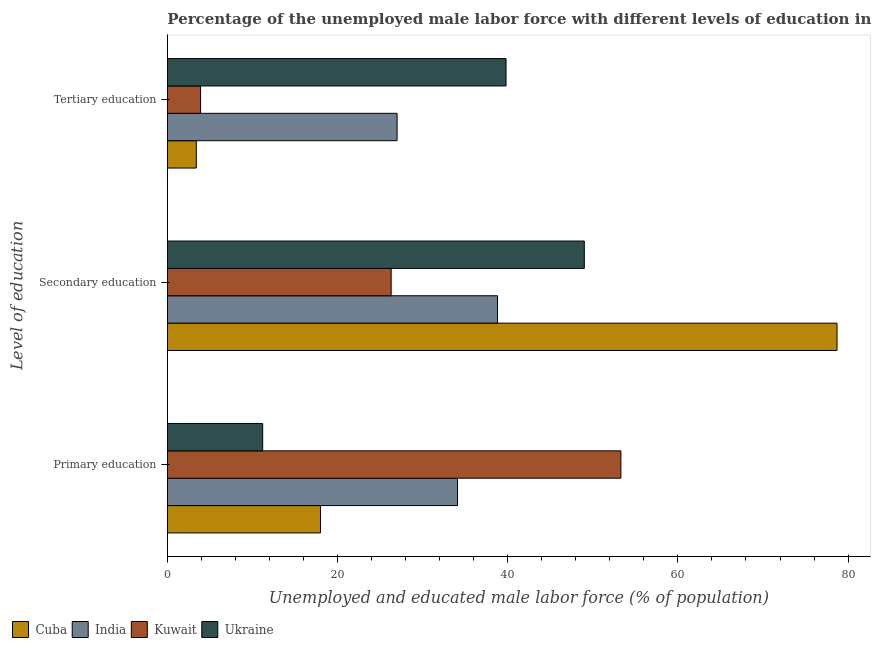How many different coloured bars are there?
Give a very brief answer. 4. Are the number of bars per tick equal to the number of legend labels?
Provide a short and direct response. Yes. How many bars are there on the 3rd tick from the bottom?
Your answer should be very brief. 4. What is the label of the 1st group of bars from the top?
Offer a very short reply. Tertiary education. What is the percentage of male labor force who received tertiary education in Kuwait?
Your response must be concise. 3.9. Across all countries, what is the maximum percentage of male labor force who received primary education?
Keep it short and to the point. 53.3. Across all countries, what is the minimum percentage of male labor force who received primary education?
Your answer should be very brief. 11.2. In which country was the percentage of male labor force who received tertiary education maximum?
Ensure brevity in your answer.  Ukraine. In which country was the percentage of male labor force who received tertiary education minimum?
Ensure brevity in your answer.  Cuba. What is the total percentage of male labor force who received secondary education in the graph?
Keep it short and to the point. 192.8. What is the difference between the percentage of male labor force who received tertiary education in Ukraine and that in Kuwait?
Provide a succinct answer. 35.9. What is the difference between the percentage of male labor force who received tertiary education in Kuwait and the percentage of male labor force who received secondary education in Cuba?
Keep it short and to the point. -74.8. What is the average percentage of male labor force who received primary education per country?
Give a very brief answer. 29.15. What is the difference between the percentage of male labor force who received tertiary education and percentage of male labor force who received secondary education in Cuba?
Your response must be concise. -75.3. In how many countries, is the percentage of male labor force who received secondary education greater than 48 %?
Offer a very short reply. 2. What is the ratio of the percentage of male labor force who received secondary education in Ukraine to that in India?
Your answer should be very brief. 1.26. Is the percentage of male labor force who received secondary education in India less than that in Kuwait?
Your answer should be compact. No. Is the difference between the percentage of male labor force who received tertiary education in Kuwait and Cuba greater than the difference between the percentage of male labor force who received secondary education in Kuwait and Cuba?
Keep it short and to the point. Yes. What is the difference between the highest and the second highest percentage of male labor force who received secondary education?
Ensure brevity in your answer.  29.7. What is the difference between the highest and the lowest percentage of male labor force who received primary education?
Your answer should be very brief. 42.1. In how many countries, is the percentage of male labor force who received tertiary education greater than the average percentage of male labor force who received tertiary education taken over all countries?
Offer a very short reply. 2. What does the 2nd bar from the top in Primary education represents?
Ensure brevity in your answer.  Kuwait. What does the 4th bar from the bottom in Tertiary education represents?
Ensure brevity in your answer.  Ukraine. Is it the case that in every country, the sum of the percentage of male labor force who received primary education and percentage of male labor force who received secondary education is greater than the percentage of male labor force who received tertiary education?
Give a very brief answer. Yes. How many countries are there in the graph?
Offer a very short reply. 4. Are the values on the major ticks of X-axis written in scientific E-notation?
Keep it short and to the point. No. Does the graph contain grids?
Your response must be concise. No. Where does the legend appear in the graph?
Offer a very short reply. Bottom left. What is the title of the graph?
Keep it short and to the point. Percentage of the unemployed male labor force with different levels of education in countries. Does "Tonga" appear as one of the legend labels in the graph?
Offer a terse response. No. What is the label or title of the X-axis?
Give a very brief answer. Unemployed and educated male labor force (% of population). What is the label or title of the Y-axis?
Provide a succinct answer. Level of education. What is the Unemployed and educated male labor force (% of population) of Cuba in Primary education?
Your answer should be compact. 18. What is the Unemployed and educated male labor force (% of population) of India in Primary education?
Keep it short and to the point. 34.1. What is the Unemployed and educated male labor force (% of population) of Kuwait in Primary education?
Give a very brief answer. 53.3. What is the Unemployed and educated male labor force (% of population) of Ukraine in Primary education?
Keep it short and to the point. 11.2. What is the Unemployed and educated male labor force (% of population) in Cuba in Secondary education?
Your answer should be very brief. 78.7. What is the Unemployed and educated male labor force (% of population) of India in Secondary education?
Give a very brief answer. 38.8. What is the Unemployed and educated male labor force (% of population) in Kuwait in Secondary education?
Provide a succinct answer. 26.3. What is the Unemployed and educated male labor force (% of population) of Cuba in Tertiary education?
Provide a short and direct response. 3.4. What is the Unemployed and educated male labor force (% of population) of India in Tertiary education?
Your answer should be compact. 27. What is the Unemployed and educated male labor force (% of population) of Kuwait in Tertiary education?
Keep it short and to the point. 3.9. What is the Unemployed and educated male labor force (% of population) of Ukraine in Tertiary education?
Keep it short and to the point. 39.8. Across all Level of education, what is the maximum Unemployed and educated male labor force (% of population) of Cuba?
Keep it short and to the point. 78.7. Across all Level of education, what is the maximum Unemployed and educated male labor force (% of population) of India?
Provide a succinct answer. 38.8. Across all Level of education, what is the maximum Unemployed and educated male labor force (% of population) in Kuwait?
Make the answer very short. 53.3. Across all Level of education, what is the minimum Unemployed and educated male labor force (% of population) of Cuba?
Keep it short and to the point. 3.4. Across all Level of education, what is the minimum Unemployed and educated male labor force (% of population) of Kuwait?
Provide a short and direct response. 3.9. Across all Level of education, what is the minimum Unemployed and educated male labor force (% of population) of Ukraine?
Your answer should be very brief. 11.2. What is the total Unemployed and educated male labor force (% of population) in Cuba in the graph?
Give a very brief answer. 100.1. What is the total Unemployed and educated male labor force (% of population) in India in the graph?
Your answer should be compact. 99.9. What is the total Unemployed and educated male labor force (% of population) in Kuwait in the graph?
Your answer should be compact. 83.5. What is the total Unemployed and educated male labor force (% of population) of Ukraine in the graph?
Your answer should be very brief. 100. What is the difference between the Unemployed and educated male labor force (% of population) in Cuba in Primary education and that in Secondary education?
Keep it short and to the point. -60.7. What is the difference between the Unemployed and educated male labor force (% of population) in Ukraine in Primary education and that in Secondary education?
Offer a very short reply. -37.8. What is the difference between the Unemployed and educated male labor force (% of population) of Kuwait in Primary education and that in Tertiary education?
Give a very brief answer. 49.4. What is the difference between the Unemployed and educated male labor force (% of population) of Ukraine in Primary education and that in Tertiary education?
Offer a very short reply. -28.6. What is the difference between the Unemployed and educated male labor force (% of population) in Cuba in Secondary education and that in Tertiary education?
Make the answer very short. 75.3. What is the difference between the Unemployed and educated male labor force (% of population) of Kuwait in Secondary education and that in Tertiary education?
Offer a terse response. 22.4. What is the difference between the Unemployed and educated male labor force (% of population) of Cuba in Primary education and the Unemployed and educated male labor force (% of population) of India in Secondary education?
Offer a terse response. -20.8. What is the difference between the Unemployed and educated male labor force (% of population) of Cuba in Primary education and the Unemployed and educated male labor force (% of population) of Ukraine in Secondary education?
Keep it short and to the point. -31. What is the difference between the Unemployed and educated male labor force (% of population) of India in Primary education and the Unemployed and educated male labor force (% of population) of Ukraine in Secondary education?
Provide a short and direct response. -14.9. What is the difference between the Unemployed and educated male labor force (% of population) of Cuba in Primary education and the Unemployed and educated male labor force (% of population) of India in Tertiary education?
Your answer should be very brief. -9. What is the difference between the Unemployed and educated male labor force (% of population) in Cuba in Primary education and the Unemployed and educated male labor force (% of population) in Kuwait in Tertiary education?
Make the answer very short. 14.1. What is the difference between the Unemployed and educated male labor force (% of population) in Cuba in Primary education and the Unemployed and educated male labor force (% of population) in Ukraine in Tertiary education?
Offer a terse response. -21.8. What is the difference between the Unemployed and educated male labor force (% of population) of India in Primary education and the Unemployed and educated male labor force (% of population) of Kuwait in Tertiary education?
Provide a short and direct response. 30.2. What is the difference between the Unemployed and educated male labor force (% of population) in India in Primary education and the Unemployed and educated male labor force (% of population) in Ukraine in Tertiary education?
Provide a short and direct response. -5.7. What is the difference between the Unemployed and educated male labor force (% of population) in Kuwait in Primary education and the Unemployed and educated male labor force (% of population) in Ukraine in Tertiary education?
Provide a succinct answer. 13.5. What is the difference between the Unemployed and educated male labor force (% of population) of Cuba in Secondary education and the Unemployed and educated male labor force (% of population) of India in Tertiary education?
Provide a short and direct response. 51.7. What is the difference between the Unemployed and educated male labor force (% of population) of Cuba in Secondary education and the Unemployed and educated male labor force (% of population) of Kuwait in Tertiary education?
Offer a terse response. 74.8. What is the difference between the Unemployed and educated male labor force (% of population) in Cuba in Secondary education and the Unemployed and educated male labor force (% of population) in Ukraine in Tertiary education?
Make the answer very short. 38.9. What is the difference between the Unemployed and educated male labor force (% of population) in India in Secondary education and the Unemployed and educated male labor force (% of population) in Kuwait in Tertiary education?
Your answer should be compact. 34.9. What is the average Unemployed and educated male labor force (% of population) of Cuba per Level of education?
Provide a short and direct response. 33.37. What is the average Unemployed and educated male labor force (% of population) in India per Level of education?
Provide a succinct answer. 33.3. What is the average Unemployed and educated male labor force (% of population) in Kuwait per Level of education?
Keep it short and to the point. 27.83. What is the average Unemployed and educated male labor force (% of population) of Ukraine per Level of education?
Keep it short and to the point. 33.33. What is the difference between the Unemployed and educated male labor force (% of population) in Cuba and Unemployed and educated male labor force (% of population) in India in Primary education?
Offer a very short reply. -16.1. What is the difference between the Unemployed and educated male labor force (% of population) in Cuba and Unemployed and educated male labor force (% of population) in Kuwait in Primary education?
Your response must be concise. -35.3. What is the difference between the Unemployed and educated male labor force (% of population) in Cuba and Unemployed and educated male labor force (% of population) in Ukraine in Primary education?
Ensure brevity in your answer.  6.8. What is the difference between the Unemployed and educated male labor force (% of population) of India and Unemployed and educated male labor force (% of population) of Kuwait in Primary education?
Ensure brevity in your answer.  -19.2. What is the difference between the Unemployed and educated male labor force (% of population) in India and Unemployed and educated male labor force (% of population) in Ukraine in Primary education?
Your response must be concise. 22.9. What is the difference between the Unemployed and educated male labor force (% of population) in Kuwait and Unemployed and educated male labor force (% of population) in Ukraine in Primary education?
Provide a short and direct response. 42.1. What is the difference between the Unemployed and educated male labor force (% of population) of Cuba and Unemployed and educated male labor force (% of population) of India in Secondary education?
Give a very brief answer. 39.9. What is the difference between the Unemployed and educated male labor force (% of population) of Cuba and Unemployed and educated male labor force (% of population) of Kuwait in Secondary education?
Make the answer very short. 52.4. What is the difference between the Unemployed and educated male labor force (% of population) of Cuba and Unemployed and educated male labor force (% of population) of Ukraine in Secondary education?
Your answer should be very brief. 29.7. What is the difference between the Unemployed and educated male labor force (% of population) in Kuwait and Unemployed and educated male labor force (% of population) in Ukraine in Secondary education?
Ensure brevity in your answer.  -22.7. What is the difference between the Unemployed and educated male labor force (% of population) in Cuba and Unemployed and educated male labor force (% of population) in India in Tertiary education?
Keep it short and to the point. -23.6. What is the difference between the Unemployed and educated male labor force (% of population) of Cuba and Unemployed and educated male labor force (% of population) of Ukraine in Tertiary education?
Provide a short and direct response. -36.4. What is the difference between the Unemployed and educated male labor force (% of population) in India and Unemployed and educated male labor force (% of population) in Kuwait in Tertiary education?
Offer a terse response. 23.1. What is the difference between the Unemployed and educated male labor force (% of population) of Kuwait and Unemployed and educated male labor force (% of population) of Ukraine in Tertiary education?
Your response must be concise. -35.9. What is the ratio of the Unemployed and educated male labor force (% of population) in Cuba in Primary education to that in Secondary education?
Ensure brevity in your answer.  0.23. What is the ratio of the Unemployed and educated male labor force (% of population) in India in Primary education to that in Secondary education?
Provide a succinct answer. 0.88. What is the ratio of the Unemployed and educated male labor force (% of population) of Kuwait in Primary education to that in Secondary education?
Your answer should be very brief. 2.03. What is the ratio of the Unemployed and educated male labor force (% of population) in Ukraine in Primary education to that in Secondary education?
Provide a short and direct response. 0.23. What is the ratio of the Unemployed and educated male labor force (% of population) in Cuba in Primary education to that in Tertiary education?
Keep it short and to the point. 5.29. What is the ratio of the Unemployed and educated male labor force (% of population) of India in Primary education to that in Tertiary education?
Make the answer very short. 1.26. What is the ratio of the Unemployed and educated male labor force (% of population) in Kuwait in Primary education to that in Tertiary education?
Provide a short and direct response. 13.67. What is the ratio of the Unemployed and educated male labor force (% of population) of Ukraine in Primary education to that in Tertiary education?
Give a very brief answer. 0.28. What is the ratio of the Unemployed and educated male labor force (% of population) in Cuba in Secondary education to that in Tertiary education?
Offer a very short reply. 23.15. What is the ratio of the Unemployed and educated male labor force (% of population) in India in Secondary education to that in Tertiary education?
Your answer should be very brief. 1.44. What is the ratio of the Unemployed and educated male labor force (% of population) in Kuwait in Secondary education to that in Tertiary education?
Offer a terse response. 6.74. What is the ratio of the Unemployed and educated male labor force (% of population) in Ukraine in Secondary education to that in Tertiary education?
Offer a very short reply. 1.23. What is the difference between the highest and the second highest Unemployed and educated male labor force (% of population) in Cuba?
Make the answer very short. 60.7. What is the difference between the highest and the second highest Unemployed and educated male labor force (% of population) of Kuwait?
Make the answer very short. 27. What is the difference between the highest and the lowest Unemployed and educated male labor force (% of population) of Cuba?
Your response must be concise. 75.3. What is the difference between the highest and the lowest Unemployed and educated male labor force (% of population) in Kuwait?
Give a very brief answer. 49.4. What is the difference between the highest and the lowest Unemployed and educated male labor force (% of population) of Ukraine?
Make the answer very short. 37.8. 